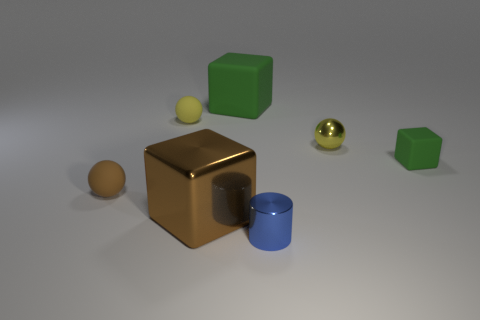Add 2 tiny brown spheres. How many objects exist? 9 Subtract all cubes. How many objects are left? 4 Subtract all big brown metal cubes. Subtract all green matte blocks. How many objects are left? 4 Add 5 brown spheres. How many brown spheres are left? 6 Add 7 cyan shiny spheres. How many cyan shiny spheres exist? 7 Subtract 0 red balls. How many objects are left? 7 